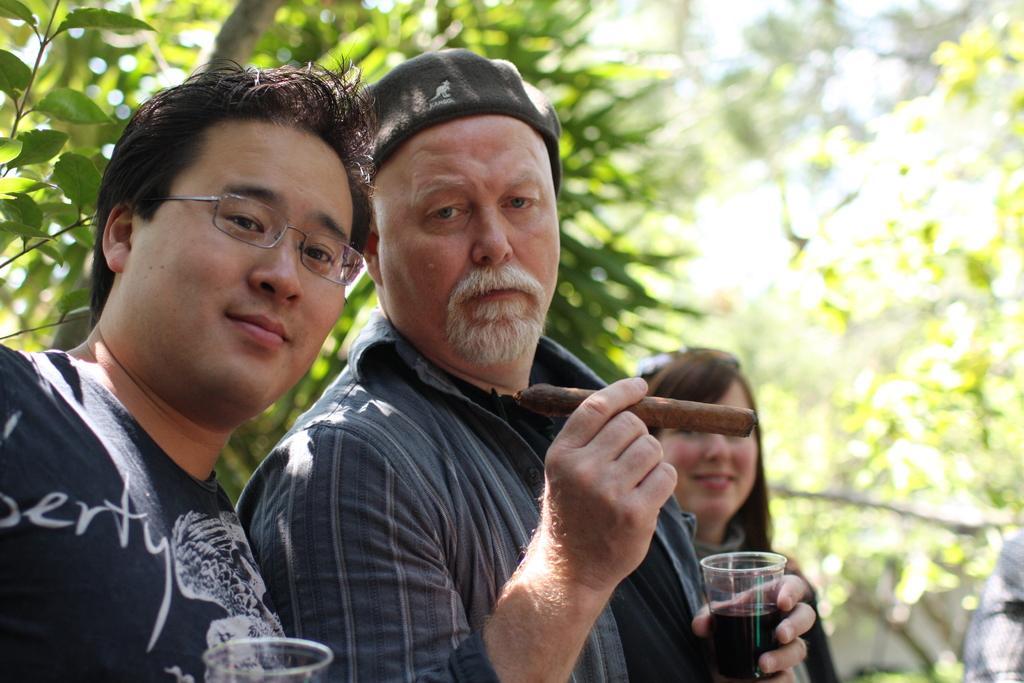Describe this image in one or two sentences. In this image, we can see three persons wearing clothes. There is a person in the middle of the image holding a cigar and glass with his hands. There are leafs in the top left of the image. In the background, image is blurred. 